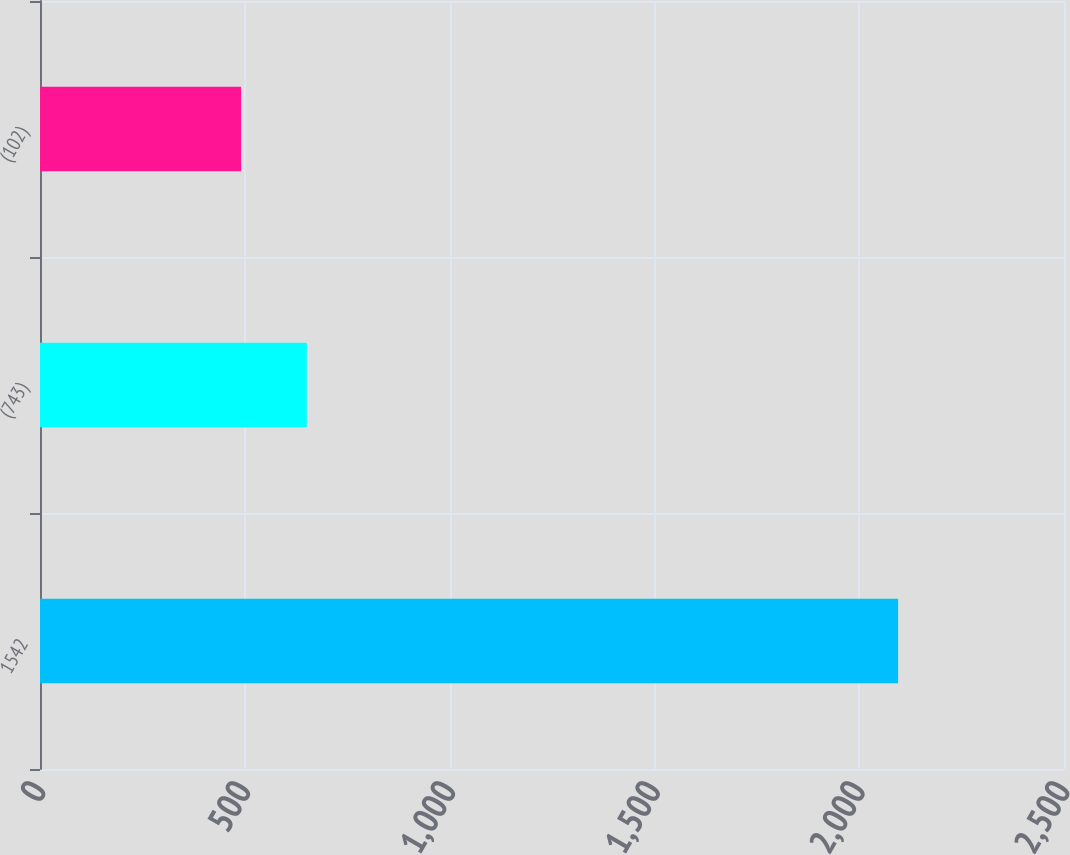Convert chart to OTSL. <chart><loc_0><loc_0><loc_500><loc_500><bar_chart><fcel>1542<fcel>(743)<fcel>(102)<nl><fcel>2095<fcel>651.4<fcel>491<nl></chart> 